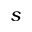<formula> <loc_0><loc_0><loc_500><loc_500>s</formula> 